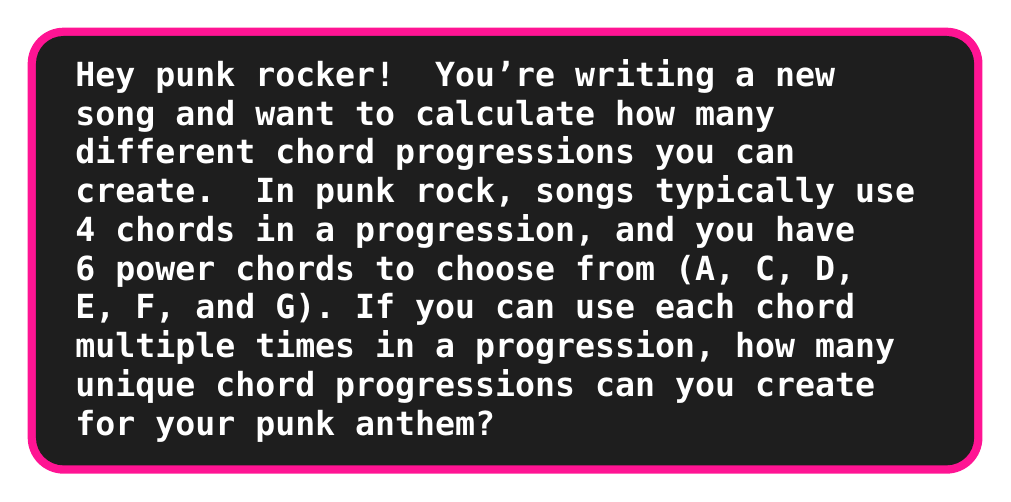What is the answer to this math problem? Let's break this down step-by-step:

1) In this scenario, we're dealing with a combination problem where:
   - We're selecting 4 chords for each progression
   - We have 6 chords to choose from
   - We can repeat chords (i.e., use the same chord more than once in a progression)
   - The order matters (e.g., A-C-D-E is different from E-D-C-A)

2) This type of problem is known as a permutation with repetition.

3) The formula for permutations with repetition is:

   $$ n^r $$

   Where:
   $n$ = number of things to choose from
   $r$ = number of times a choice is made

4) In our case:
   $n = 6$ (6 chords to choose from)
   $r = 4$ (4 chords in each progression)

5) Plugging these values into our formula:

   $$ 6^4 $$

6) Now, let's calculate:

   $$ 6^4 = 6 \times 6 \times 6 \times 6 = 1,296 $$

Therefore, you can create 1,296 unique chord progressions for your punk rock song!
Answer: $$ 6^4 = 1,296 $$ 